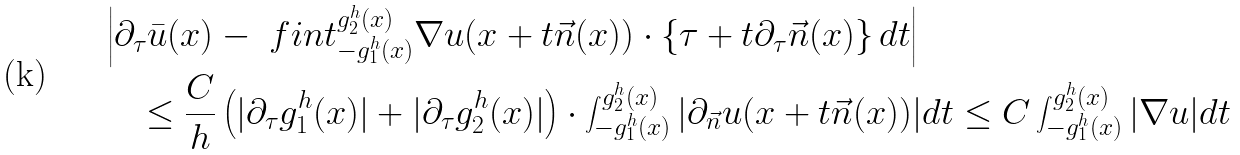Convert formula to latex. <formula><loc_0><loc_0><loc_500><loc_500>& \left | \partial _ { \tau } \bar { u } ( x ) - \ f i n t _ { - g _ { 1 } ^ { h } ( x ) } ^ { g _ { 2 } ^ { h } ( x ) } \nabla u ( x + t \vec { n } ( x ) ) \cdot \left \{ \tau + t \partial _ { \tau } \vec { n } ( x ) \right \} d t \right | \\ & \quad \leq \frac { C } { h } \left ( | \partial _ { \tau } g _ { 1 } ^ { h } ( x ) | + | \partial _ { \tau } g _ { 2 } ^ { h } ( x ) | \right ) \cdot \int _ { - g _ { 1 } ^ { h } ( x ) } ^ { g _ { 2 } ^ { h } ( x ) } | \partial _ { \vec { n } } u ( x + t \vec { n } ( x ) ) | d t \leq C \int _ { - g _ { 1 } ^ { h } ( x ) } ^ { g _ { 2 } ^ { h } ( x ) } | \nabla u | d t</formula> 